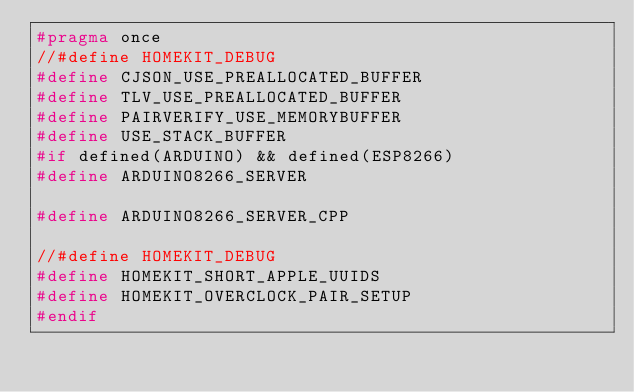Convert code to text. <code><loc_0><loc_0><loc_500><loc_500><_C_>#pragma once
//#define HOMEKIT_DEBUG
#define CJSON_USE_PREALLOCATED_BUFFER
#define TLV_USE_PREALLOCATED_BUFFER
#define PAIRVERIFY_USE_MEMORYBUFFER
#define USE_STACK_BUFFER
#if defined(ARDUINO) && defined(ESP8266)
#define ARDUINO8266_SERVER

#define ARDUINO8266_SERVER_CPP

//#define HOMEKIT_DEBUG
#define HOMEKIT_SHORT_APPLE_UUIDS
#define HOMEKIT_OVERCLOCK_PAIR_SETUP
#endif </code> 